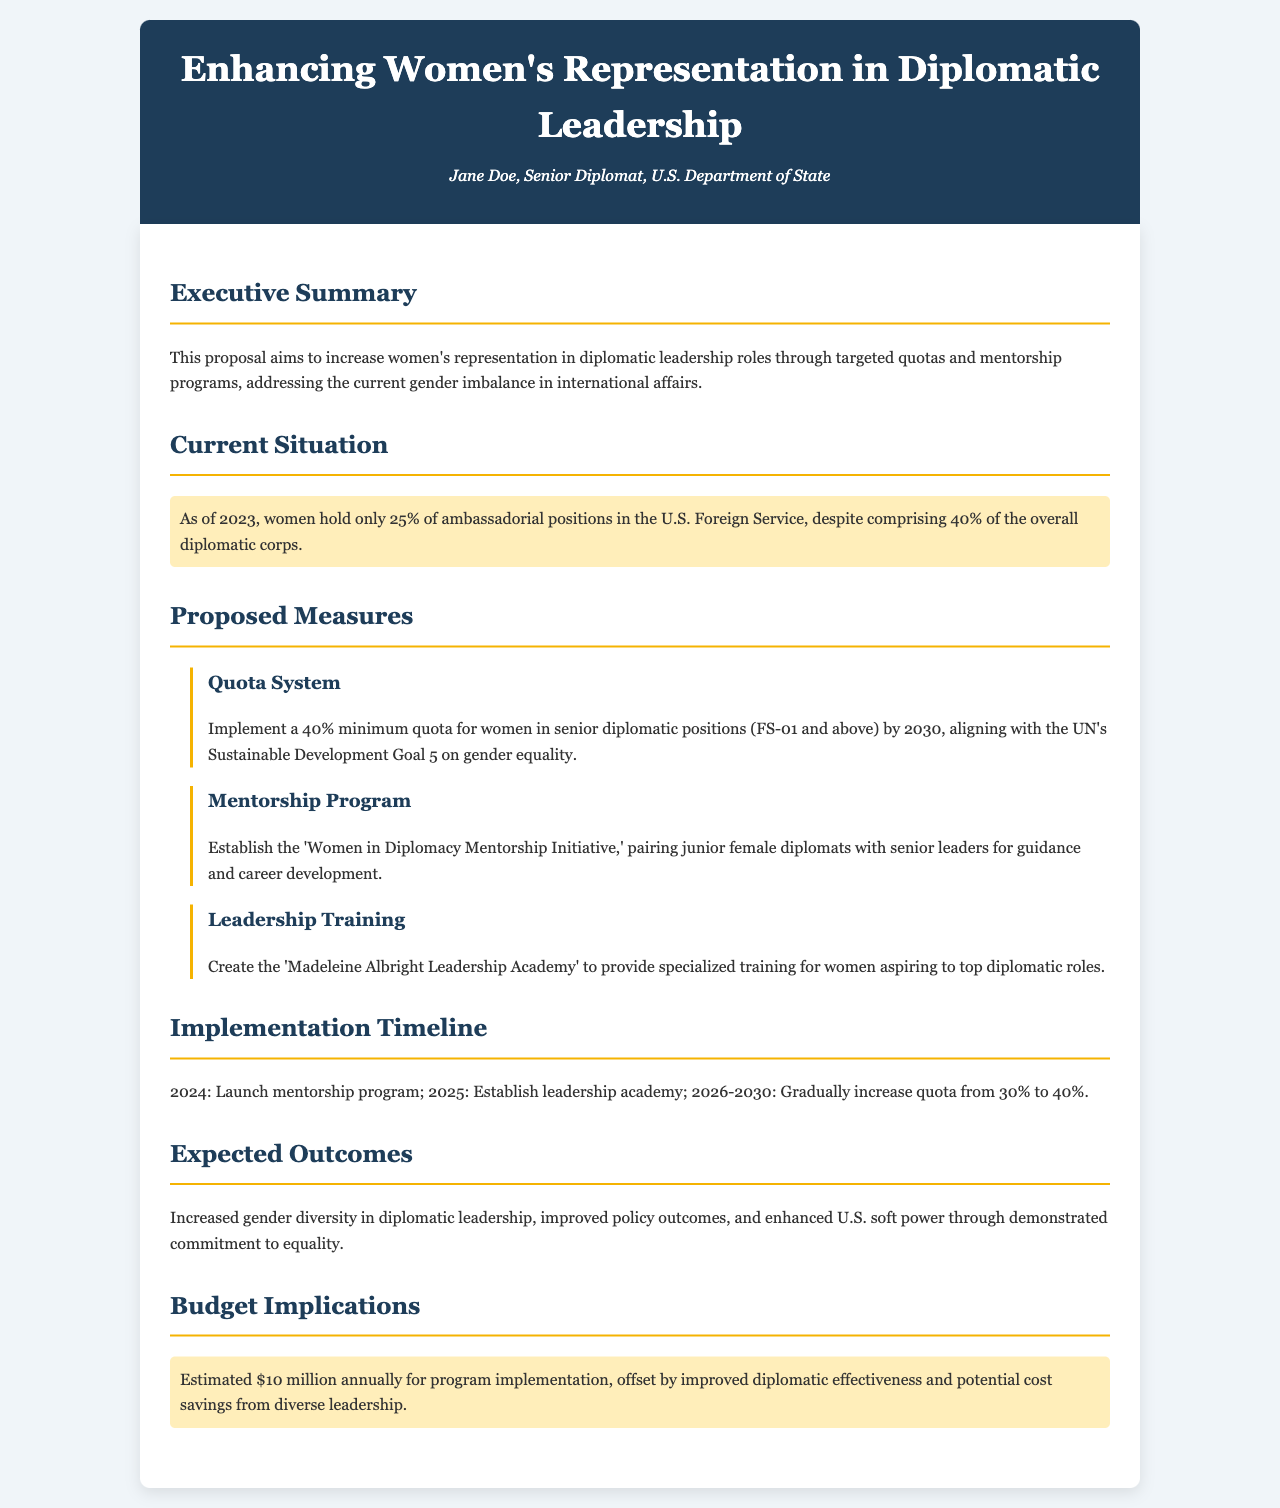What percentage of ambassadorial positions are held by women? The document states that as of 2023, women hold only 25% of ambassadorial positions in the U.S. Foreign Service.
Answer: 25% What is the proposed minimum quota for women in senior diplomatic positions? The document proposes a 40% minimum quota for women in senior diplomatic positions (FS-01 and above).
Answer: 40% When is the mentorship program scheduled to launch? The implementation timeline indicates the mentorship program will launch in 2024.
Answer: 2024 What is the name of the proposed leadership training program? The document mentions the 'Madeleine Albright Leadership Academy' as the proposed leadership training program.
Answer: Madeleine Albright Leadership Academy How much is the estimated budget for program implementation? The document highlights an estimated $10 million annually for program implementation.
Answer: $10 million What is the expected outcome regarding U.S. soft power? The document states that the expected outcome includes enhanced U.S. soft power through demonstrated commitment to equality.
Answer: Enhanced U.S. soft power What year is the target for gradually increasing the quota to 40%? The proposed quota increase is aimed for completion by 2030.
Answer: 2030 What is the main goal of the policy proposal? The main goal is to increase women's representation in diplomatic leadership roles.
Answer: Increase women's representation in diplomatic leadership roles 